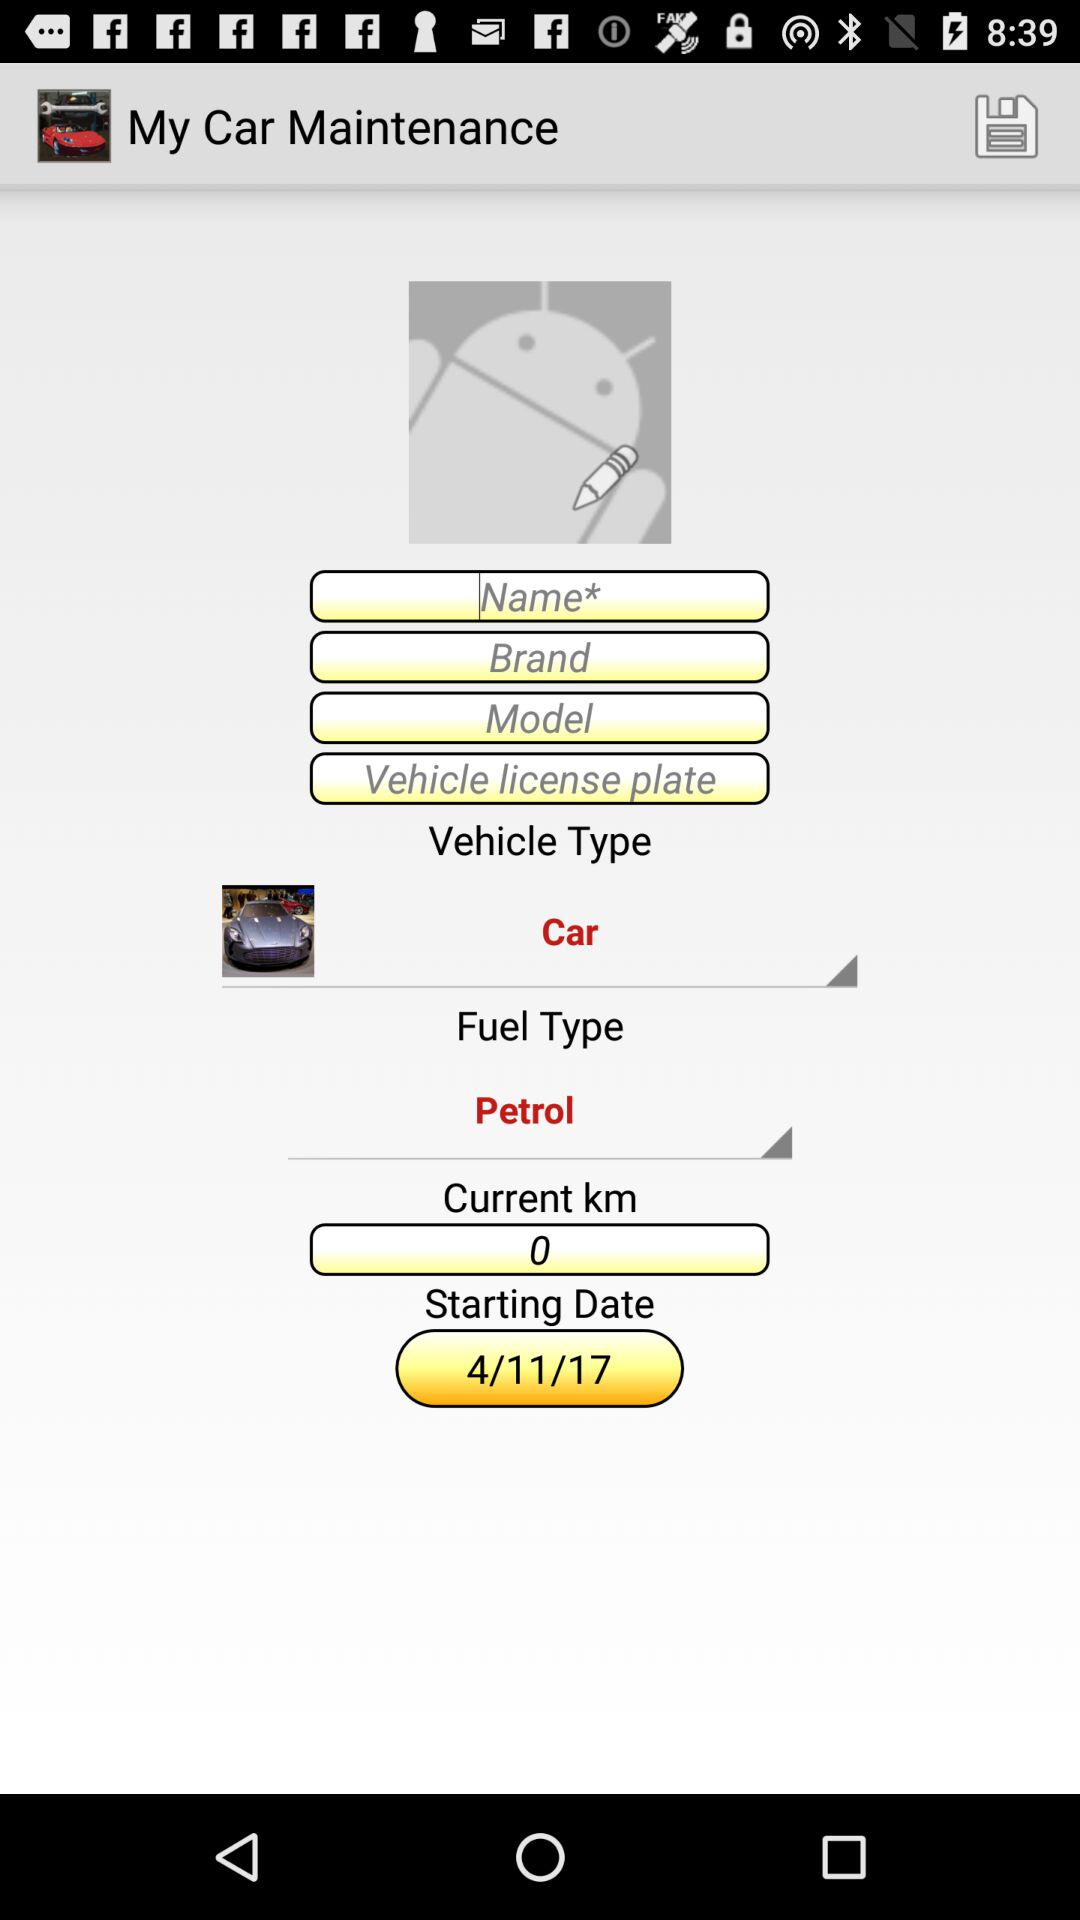What is the vehicle type? The vehicle type is "Car". 